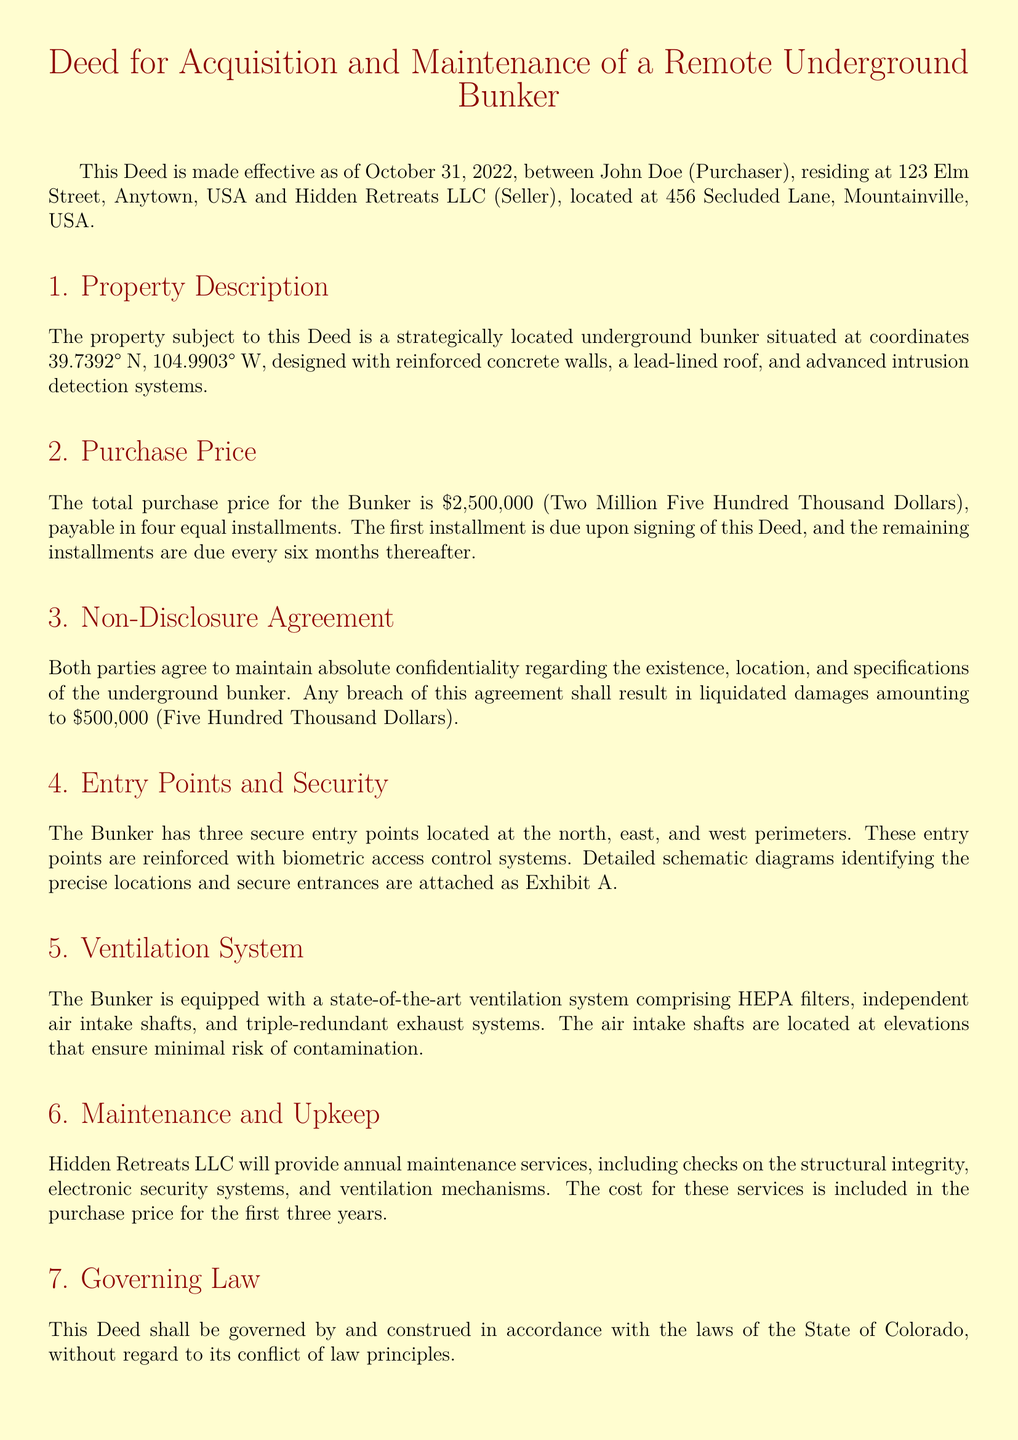What is the total purchase price for the Bunker? The total purchase price is stated in the document as $2,500,000 (Two Million Five Hundred Thousand Dollars).
Answer: $2,500,000 Who are the parties involved in the Deed? The parties involved in the Deed are John Doe and Hidden Retreats LLC.
Answer: John Doe and Hidden Retreats LLC When was the Deed made effective? The effective date of the Deed is explicitly stated in the document as October 31, 2022.
Answer: October 31, 2022 How many secure entry points does the Bunker have? The document mentions that the Bunker has three secure entry points.
Answer: Three What is the liquidated damages amount for a breach of the non-disclosure agreement? The document specifies that the liquidated damages for a breach are $500,000 (Five Hundred Thousand Dollars).
Answer: $500,000 What are the locations of the secure entry points? The secure entry points are located at the north, east, and west perimeters of the Bunker.
Answer: North, East, and West What does the ventilation system include? The ventilation system includes HEPA filters, independent air intake shafts, and triple-redundant exhaust systems.
Answer: HEPA filters, independent air intake shafts, and triple-redundant exhaust systems For how long are the maintenance services included in the purchase price? The document states that maintenance services are included for the first three years.
Answer: Three years What is the governing law of the Deed? The governing law stated in the document is the laws of the State of Colorado.
Answer: State of Colorado 